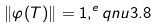Convert formula to latex. <formula><loc_0><loc_0><loc_500><loc_500>\| \varphi ^ { } ( T ) \| = 1 , ^ { e } q n u { 3 . 8 }</formula> 